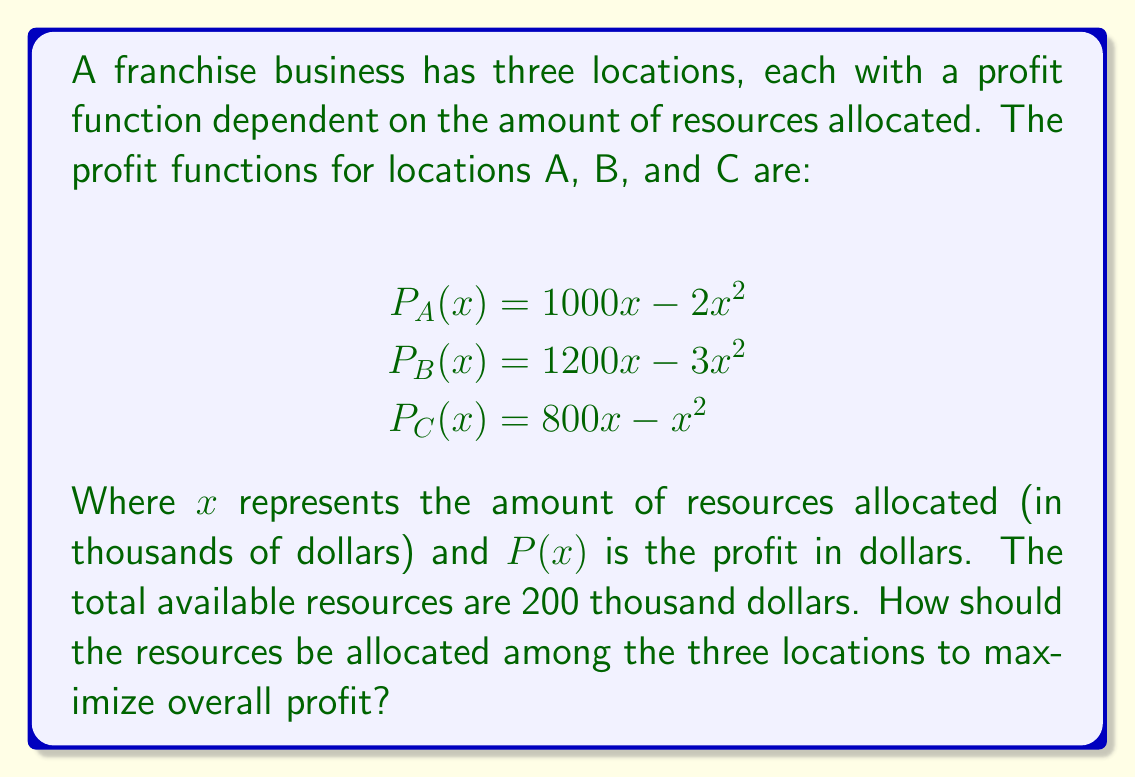Give your solution to this math problem. To solve this optimization problem, we'll use the method of Lagrange multipliers:

1) Let the total profit function be $P(x,y,z) = P_A(x) + P_B(y) + P_C(z)$
   $P(x,y,z) = (1000x - 2x^2) + (1200y - 3y^2) + (800z - z^2)$

2) The constraint is $x + y + z = 200$

3) Form the Lagrangian function:
   $L(x,y,z,\lambda) = (1000x - 2x^2) + (1200y - 3y^2) + (800z - z^2) - \lambda(x + y + z - 200)$

4) Take partial derivatives and set them to zero:
   $\frac{\partial L}{\partial x} = 1000 - 4x - \lambda = 0$
   $\frac{\partial L}{\partial y} = 1200 - 6y - \lambda = 0$
   $\frac{\partial L}{\partial z} = 800 - 2z - \lambda = 0$
   $\frac{\partial L}{\partial \lambda} = x + y + z - 200 = 0$

5) From these equations:
   $x = \frac{1000 - \lambda}{4}$
   $y = \frac{1200 - \lambda}{6}$
   $z = \frac{800 - \lambda}{2}$

6) Substitute these into the constraint equation:
   $\frac{1000 - \lambda}{4} + \frac{1200 - \lambda}{6} + \frac{800 - \lambda}{2} = 200$

7) Solve for $\lambda$:
   $\lambda = 600$

8) Substitute back to find x, y, and z:
   $x = \frac{1000 - 600}{4} = 100$
   $y = \frac{1200 - 600}{6} = 100$
   $z = \frac{800 - 600}{2} = 100$

Therefore, to maximize overall profit, the resources should be allocated equally among the three locations.
Answer: Allocate $100,000 to each location. 